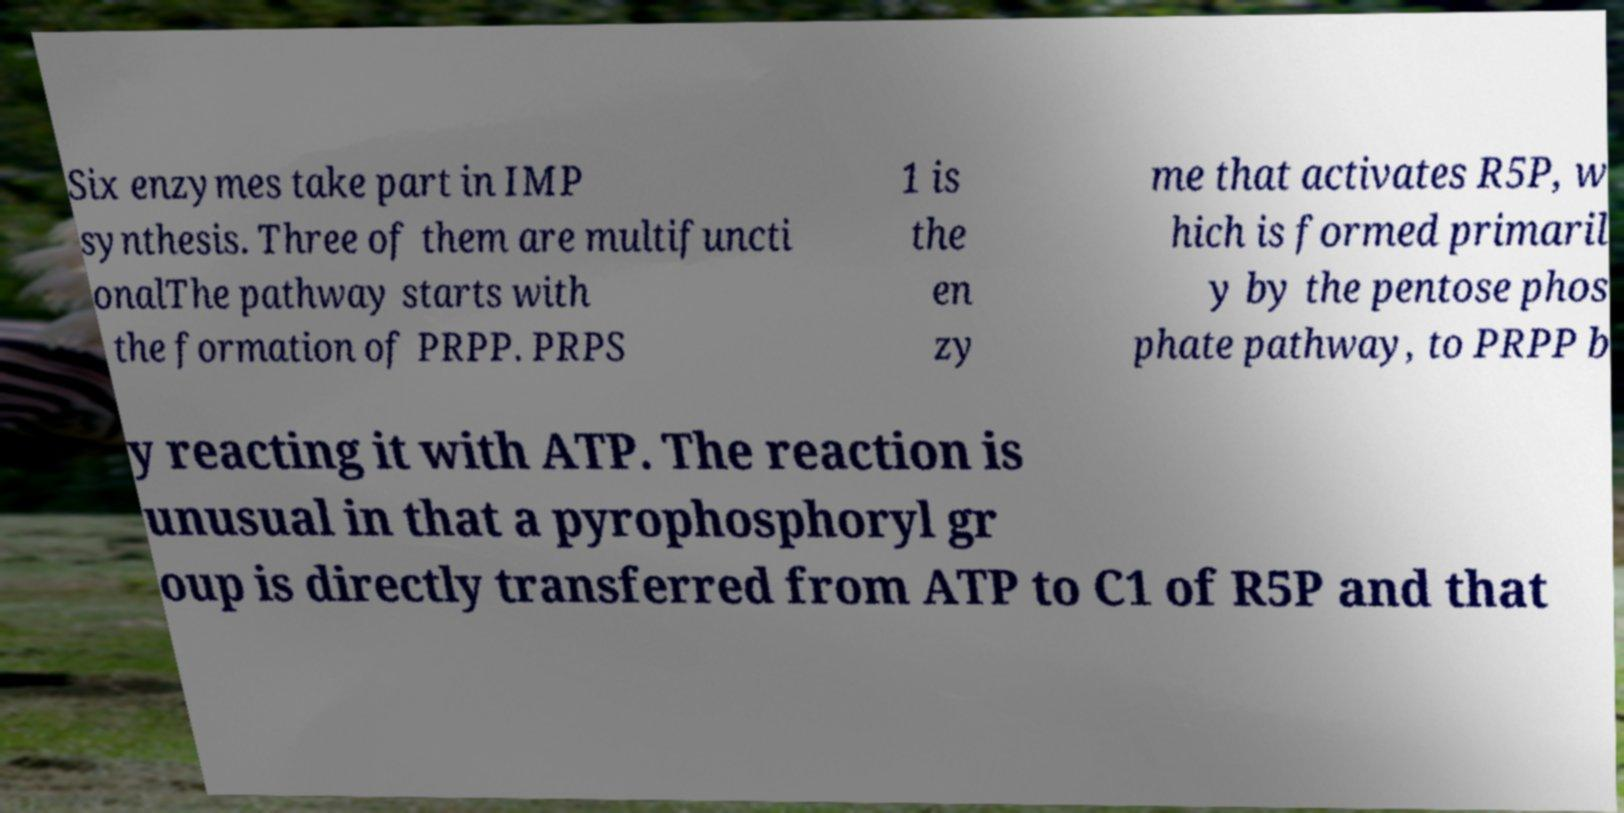Could you extract and type out the text from this image? Six enzymes take part in IMP synthesis. Three of them are multifuncti onalThe pathway starts with the formation of PRPP. PRPS 1 is the en zy me that activates R5P, w hich is formed primaril y by the pentose phos phate pathway, to PRPP b y reacting it with ATP. The reaction is unusual in that a pyrophosphoryl gr oup is directly transferred from ATP to C1 of R5P and that 